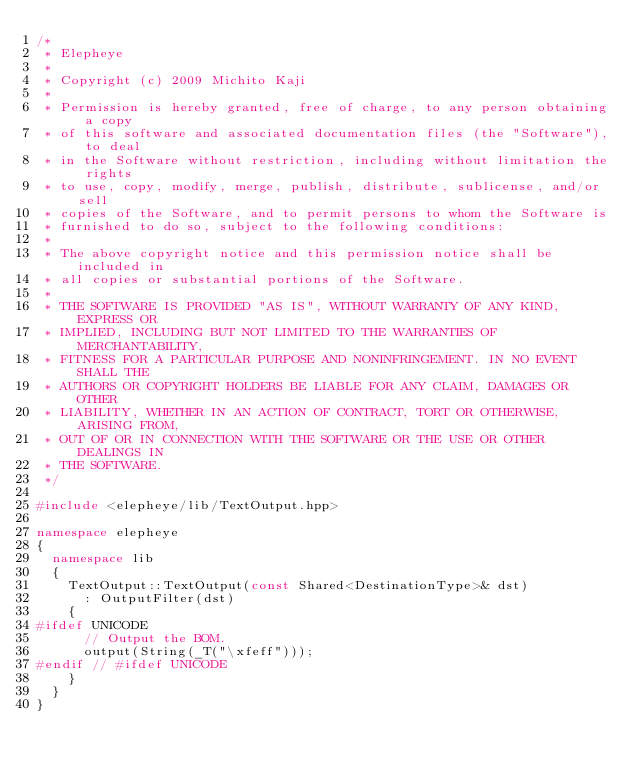<code> <loc_0><loc_0><loc_500><loc_500><_C++_>/*
 * Elepheye
 *
 * Copyright (c) 2009 Michito Kaji
 *
 * Permission is hereby granted, free of charge, to any person obtaining a copy
 * of this software and associated documentation files (the "Software"), to deal
 * in the Software without restriction, including without limitation the rights
 * to use, copy, modify, merge, publish, distribute, sublicense, and/or sell
 * copies of the Software, and to permit persons to whom the Software is
 * furnished to do so, subject to the following conditions:
 *
 * The above copyright notice and this permission notice shall be included in
 * all copies or substantial portions of the Software.
 *
 * THE SOFTWARE IS PROVIDED "AS IS", WITHOUT WARRANTY OF ANY KIND, EXPRESS OR
 * IMPLIED, INCLUDING BUT NOT LIMITED TO THE WARRANTIES OF MERCHANTABILITY,
 * FITNESS FOR A PARTICULAR PURPOSE AND NONINFRINGEMENT. IN NO EVENT SHALL THE
 * AUTHORS OR COPYRIGHT HOLDERS BE LIABLE FOR ANY CLAIM, DAMAGES OR OTHER
 * LIABILITY, WHETHER IN AN ACTION OF CONTRACT, TORT OR OTHERWISE, ARISING FROM,
 * OUT OF OR IN CONNECTION WITH THE SOFTWARE OR THE USE OR OTHER DEALINGS IN
 * THE SOFTWARE.
 */

#include <elepheye/lib/TextOutput.hpp>

namespace elepheye
{
  namespace lib
  {
    TextOutput::TextOutput(const Shared<DestinationType>& dst)
      : OutputFilter(dst)
    {
#ifdef UNICODE
      // Output the BOM.
      output(String(_T("\xfeff")));
#endif // #ifdef UNICODE
    }
  }
}
</code> 